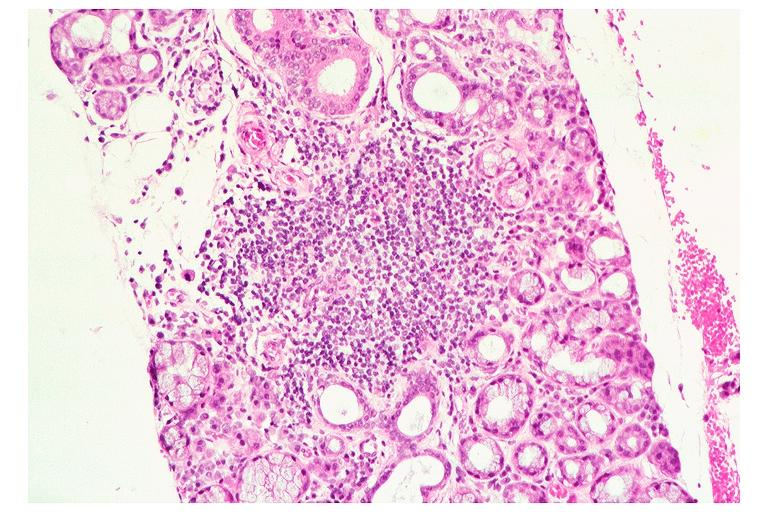what is present?
Answer the question using a single word or phrase. Oral 